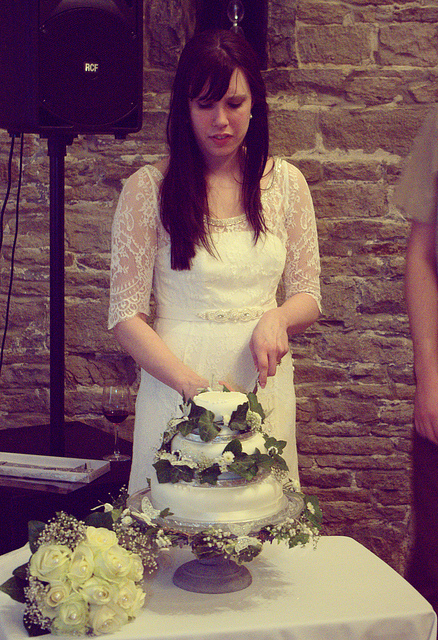Extract all visible text content from this image. ROF 